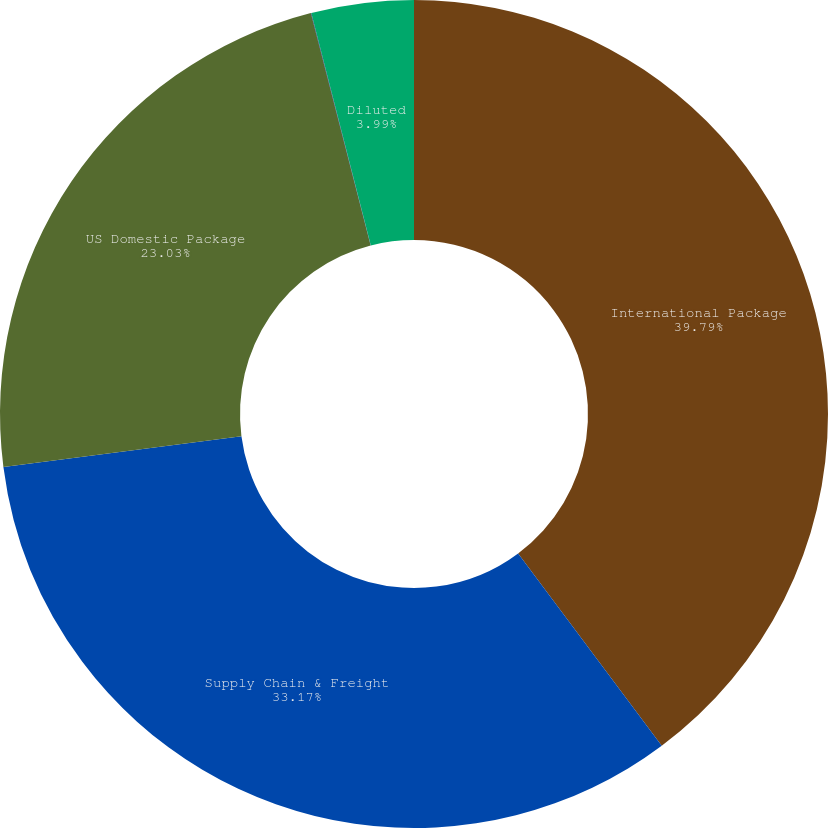<chart> <loc_0><loc_0><loc_500><loc_500><pie_chart><fcel>International Package<fcel>Supply Chain & Freight<fcel>US Domestic Package<fcel>Basic<fcel>Diluted<nl><fcel>39.79%<fcel>33.17%<fcel>23.03%<fcel>0.02%<fcel>3.99%<nl></chart> 